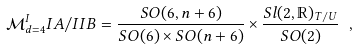<formula> <loc_0><loc_0><loc_500><loc_500>\mathcal { M } _ { d = 4 } ^ { I } I A / I I B = \frac { S O ( 6 , n + 6 ) } { S O ( 6 ) \times S O ( n + 6 ) } \times \frac { S l ( 2 , \mathbb { R } ) _ { T / U } } { S O ( 2 ) } \ ,</formula> 